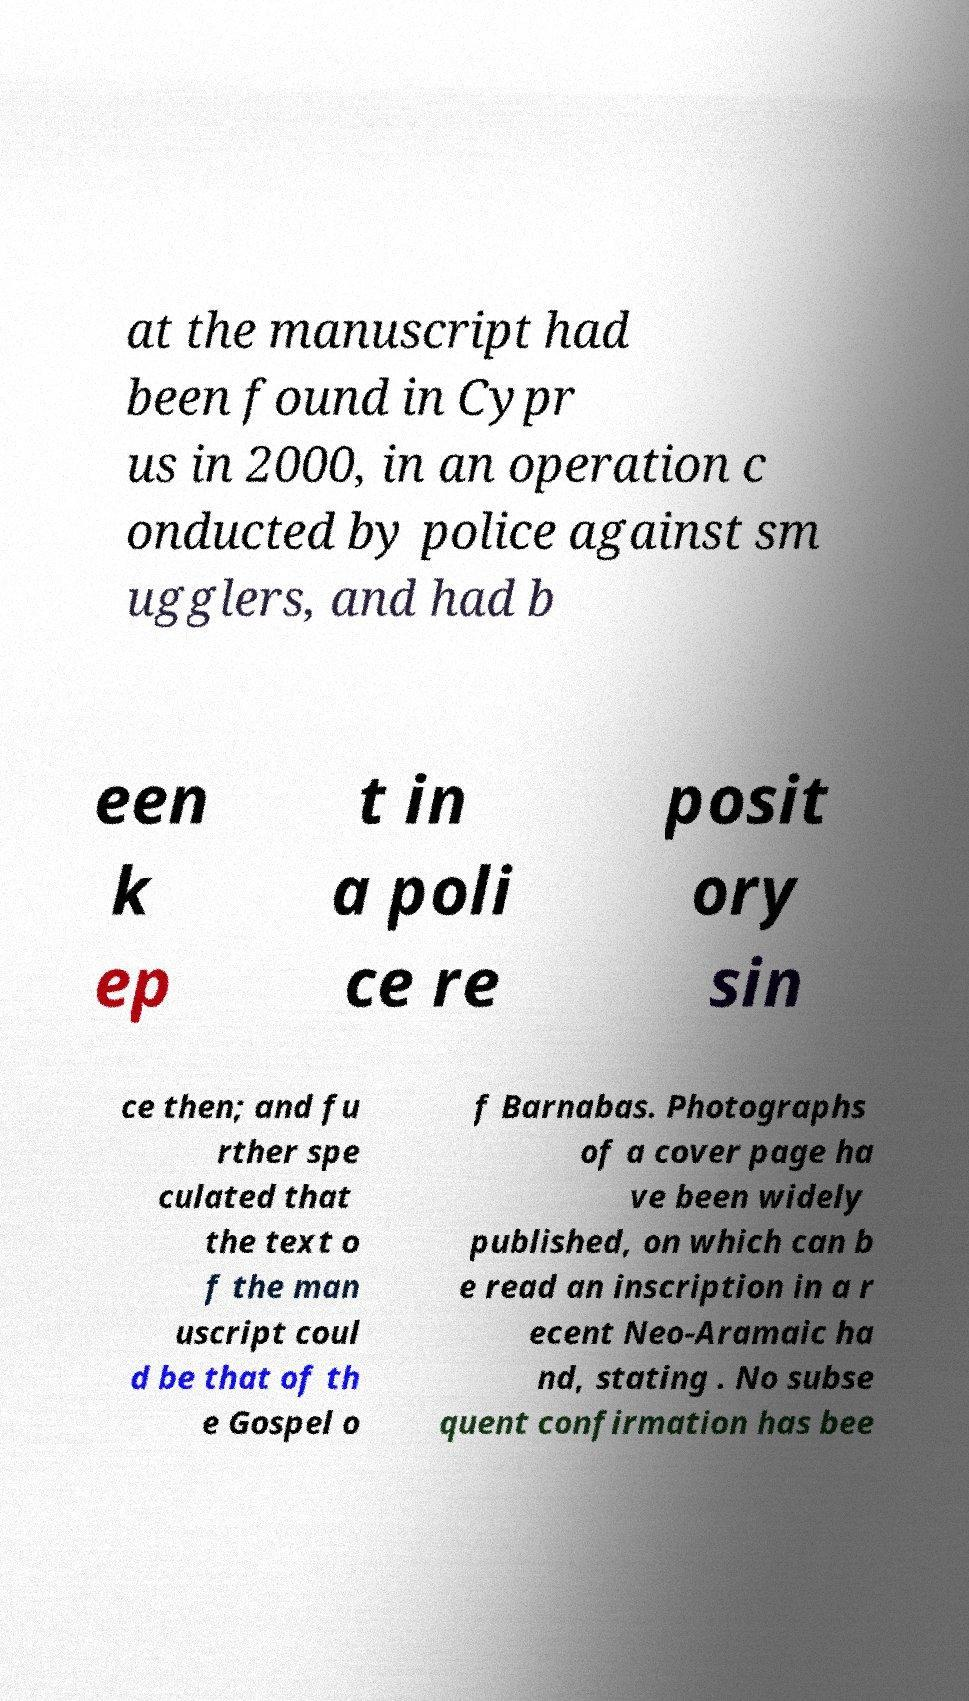Please read and relay the text visible in this image. What does it say? at the manuscript had been found in Cypr us in 2000, in an operation c onducted by police against sm ugglers, and had b een k ep t in a poli ce re posit ory sin ce then; and fu rther spe culated that the text o f the man uscript coul d be that of th e Gospel o f Barnabas. Photographs of a cover page ha ve been widely published, on which can b e read an inscription in a r ecent Neo-Aramaic ha nd, stating . No subse quent confirmation has bee 